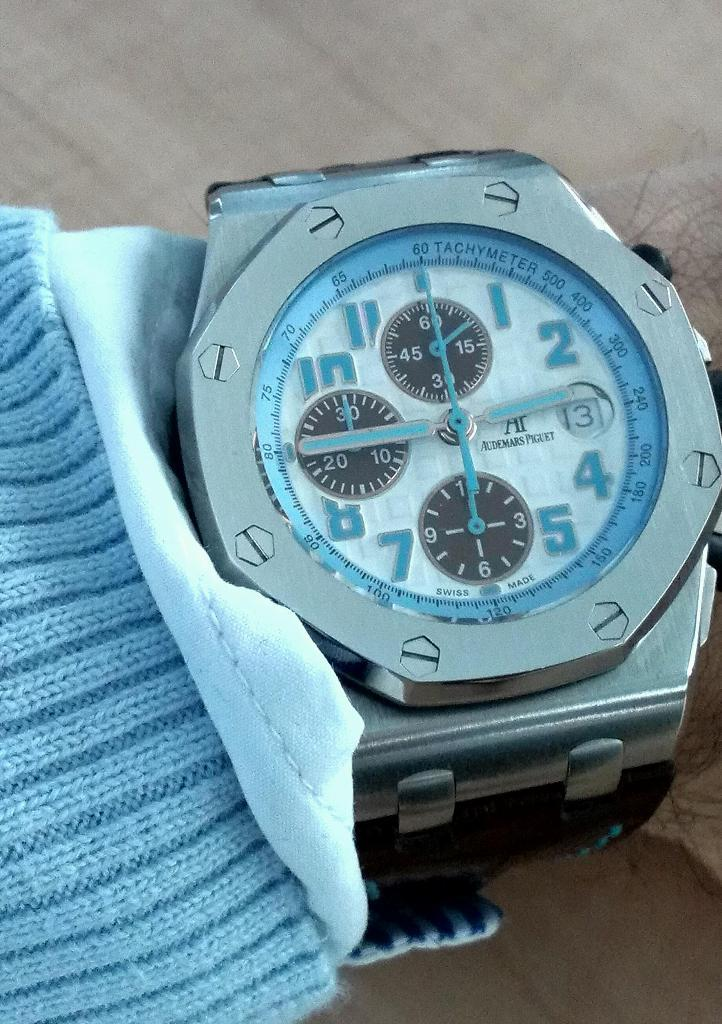<image>
Summarize the visual content of the image. Person wearing a blue and silver watch that says "Tachymeter" on it. 